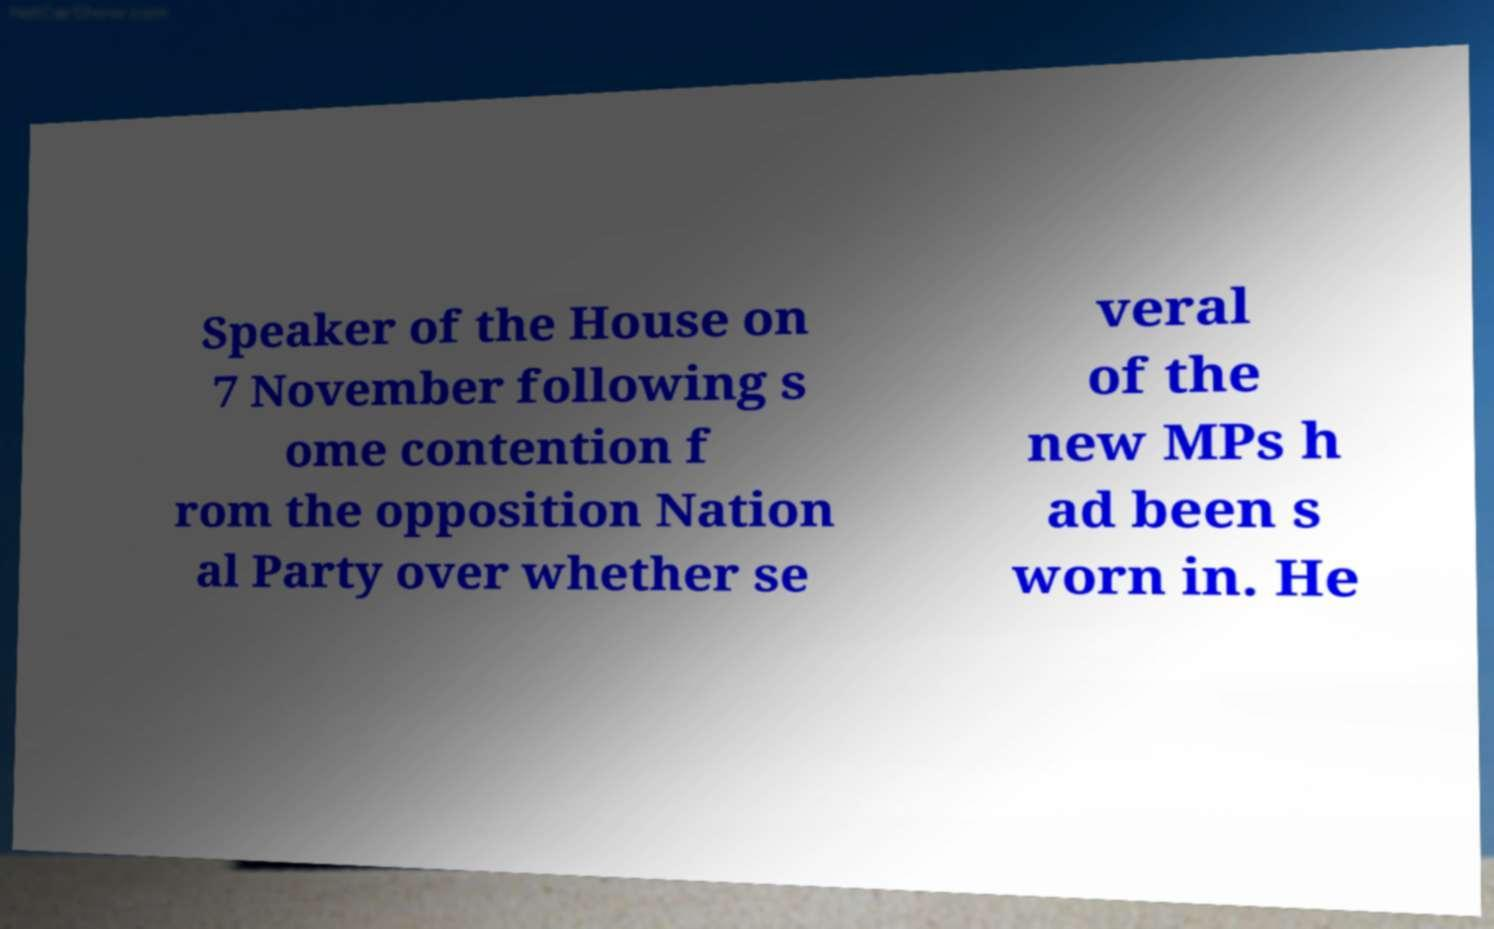I need the written content from this picture converted into text. Can you do that? Speaker of the House on 7 November following s ome contention f rom the opposition Nation al Party over whether se veral of the new MPs h ad been s worn in. He 